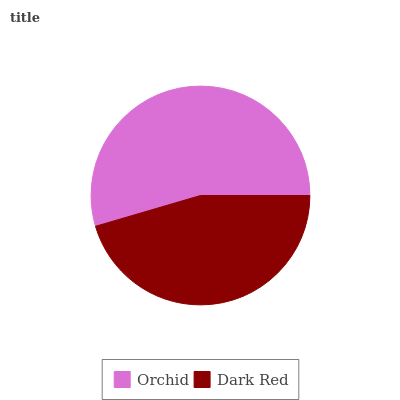Is Dark Red the minimum?
Answer yes or no. Yes. Is Orchid the maximum?
Answer yes or no. Yes. Is Dark Red the maximum?
Answer yes or no. No. Is Orchid greater than Dark Red?
Answer yes or no. Yes. Is Dark Red less than Orchid?
Answer yes or no. Yes. Is Dark Red greater than Orchid?
Answer yes or no. No. Is Orchid less than Dark Red?
Answer yes or no. No. Is Orchid the high median?
Answer yes or no. Yes. Is Dark Red the low median?
Answer yes or no. Yes. Is Dark Red the high median?
Answer yes or no. No. Is Orchid the low median?
Answer yes or no. No. 